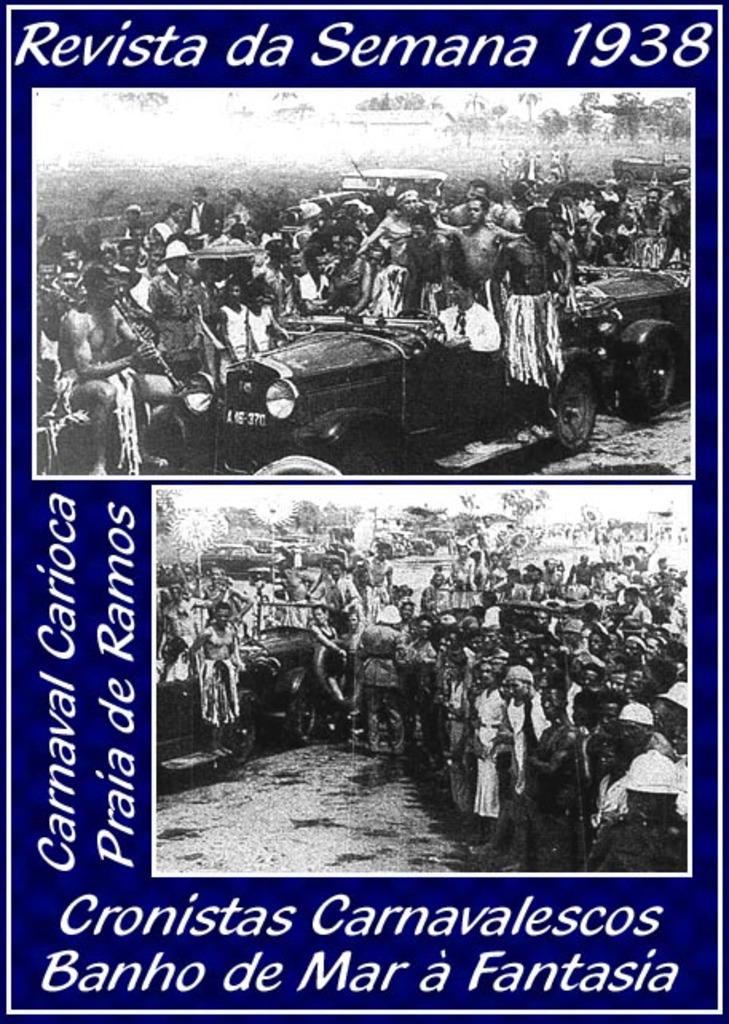Could you give a brief overview of what you see in this image? There is a poster, on which, there are two images and white color texts. In the two images, there are persons, vehicles, trees and there is a sky. The background is violet in color. 